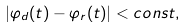Convert formula to latex. <formula><loc_0><loc_0><loc_500><loc_500>| \varphi _ { d } ( t ) - \varphi _ { r } ( t ) | < c o n s t ,</formula> 